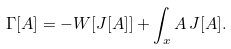<formula> <loc_0><loc_0><loc_500><loc_500>\Gamma [ A ] = - W [ J [ A ] ] + \int _ { x } A \, J [ A ] .</formula> 